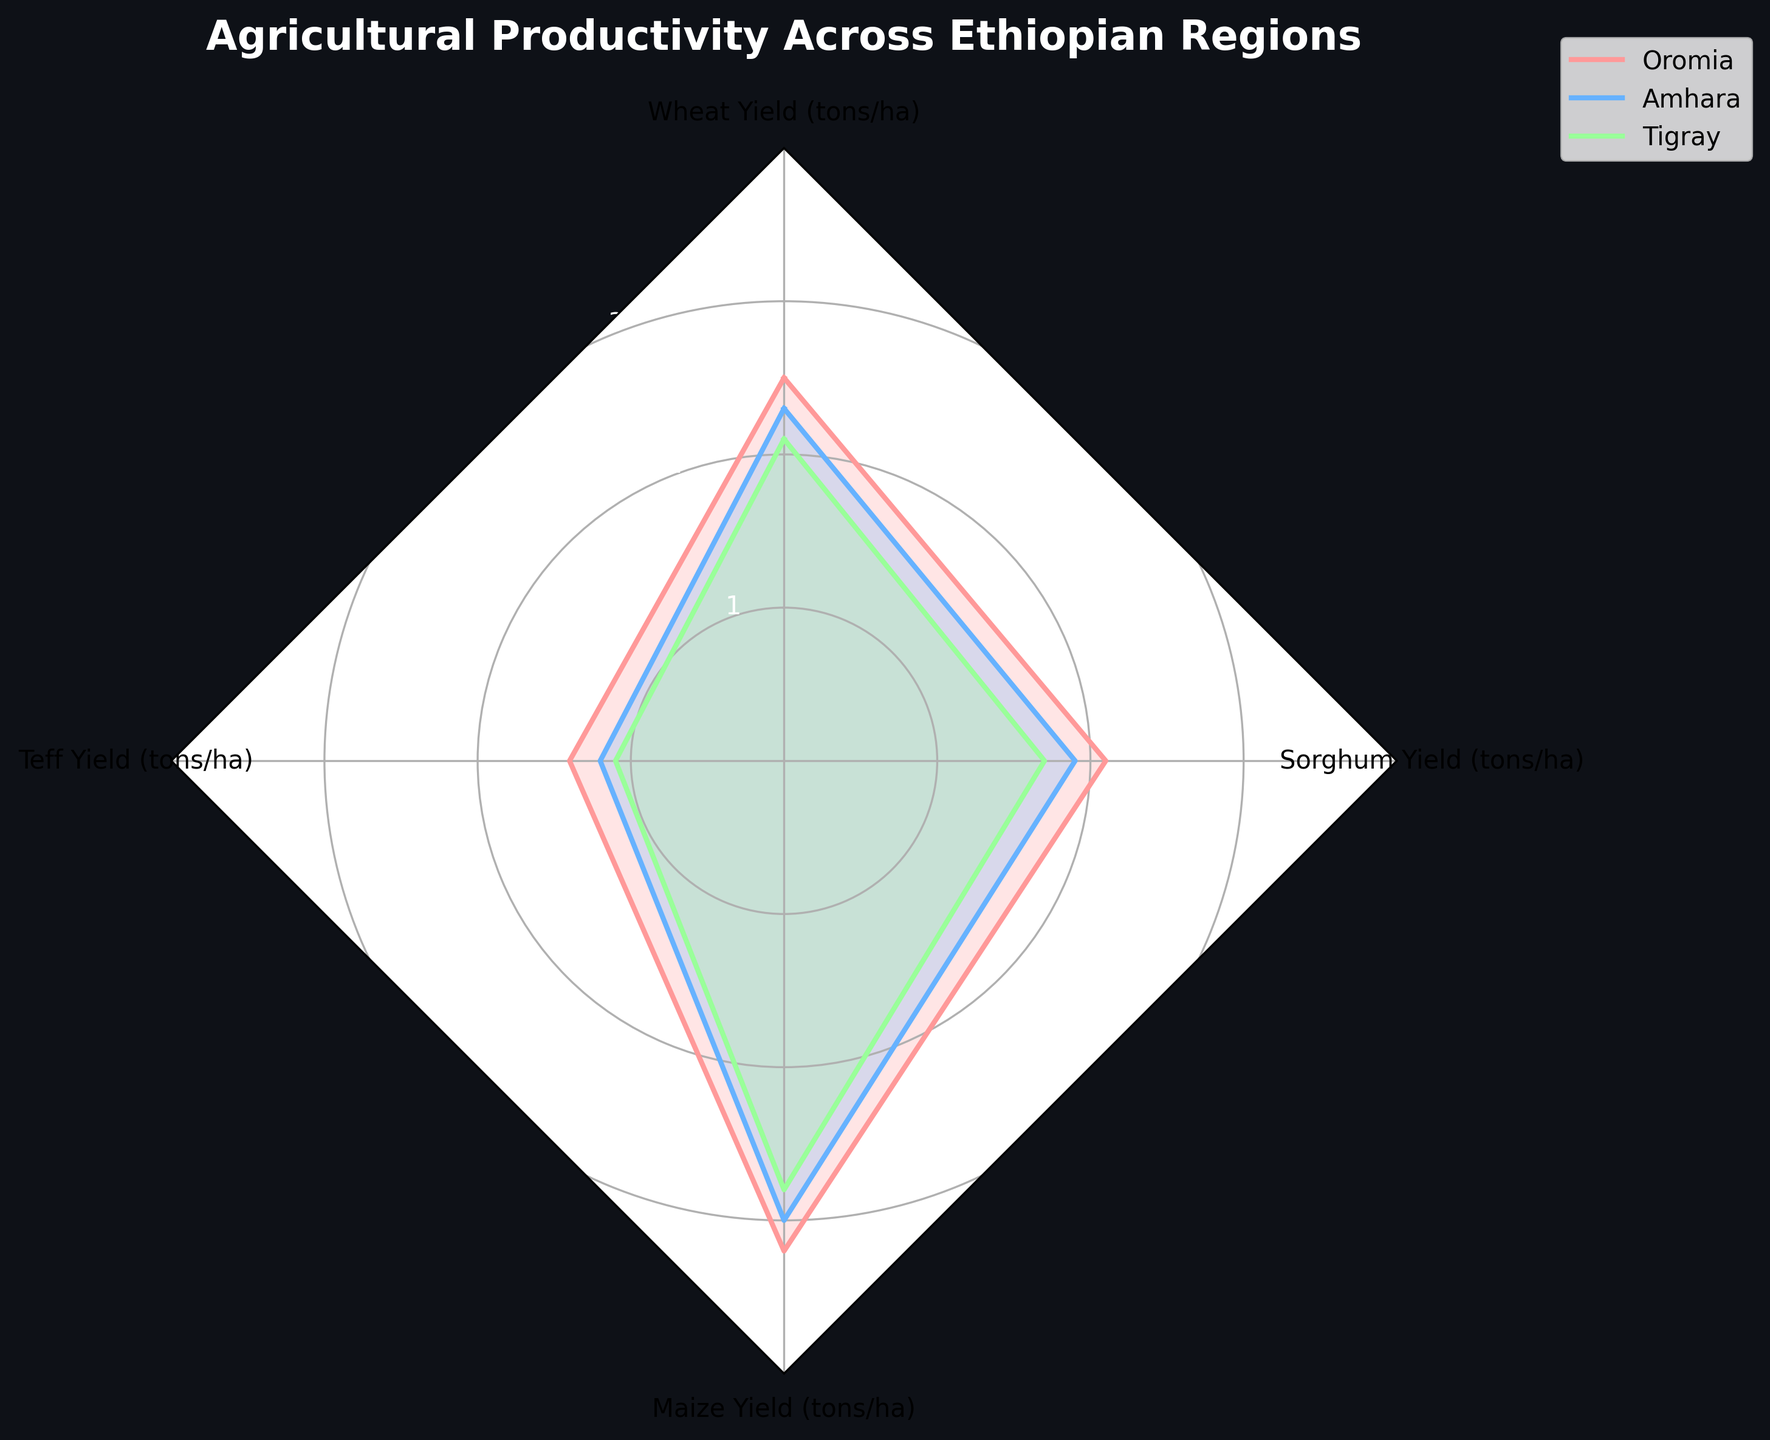What is the title of the plot? The title of the plot is located at the top center of the figure and is written in bold and larger font size for easy visibility.
Answer: Agricultural Productivity Across Ethiopian Regions How many different regions are compared in the radar chart? The plot legend shows the regions compared in the chart, each in a different color. From the legend, we can identify three regions.
Answer: Three Which region has the highest wheat yield? Observing the radial line corresponding to 'Wheat Yield (tons/ha)' and noting the outermost point along that line, it can be seen that Oromia has the highest value.
Answer: Oromia Which crop shows the lowest yield in Tigray? Looking directly at the Tigray dataset on the radar chart and identifying the innermost point among the four crops, Teff Yield shows the lowest value in the Tigray region.
Answer: Teff Between Oromia and Amhara, which region has a higher Teff yield? By comparing the points along the 'Teff Yield (tons/ha)' axis for both Oromia and Amhara, we can see that the point for Oromia is slightly further outwards than that for Amhara.
Answer: Oromia Calculate the average maize yield across all regions. Extract the maize yield values for Oromia, Amhara, and Tigray: 3.2, 3.0, and 2.8 respectively. Summing these gives 9. Then, divide by the number of regions, which is 3. The computation is (3.2 + 3.0 + 2.8) / 3.
Answer: 3.0 Between Sorghum yield and Maize yield in Amhara, which is higher? Observing the points along the 'Sorghum Yield (tons/ha)' and 'Maize Yield (tons/ha)' axes for Amhara, it is evident that the point for Maize yield is farther outwards compared to the Sorghum yield.
Answer: Maize Rank the crops in descending order of yield in Oromia. By looking at the points along each crop's respective line for Oromia, we can see the order from the outermost to the innermost points. The ranking is Maize, Wheat, Sorghum, Teff.
Answer: Maize, Wheat, Sorghum, Teff Which region shows the least variation in crop yields? Variation can be inferred by noting the distance between the closest and farthest points from the center for each region. Tigray has the points closer together compared to Oromia and Amhara.
Answer: Tigray 